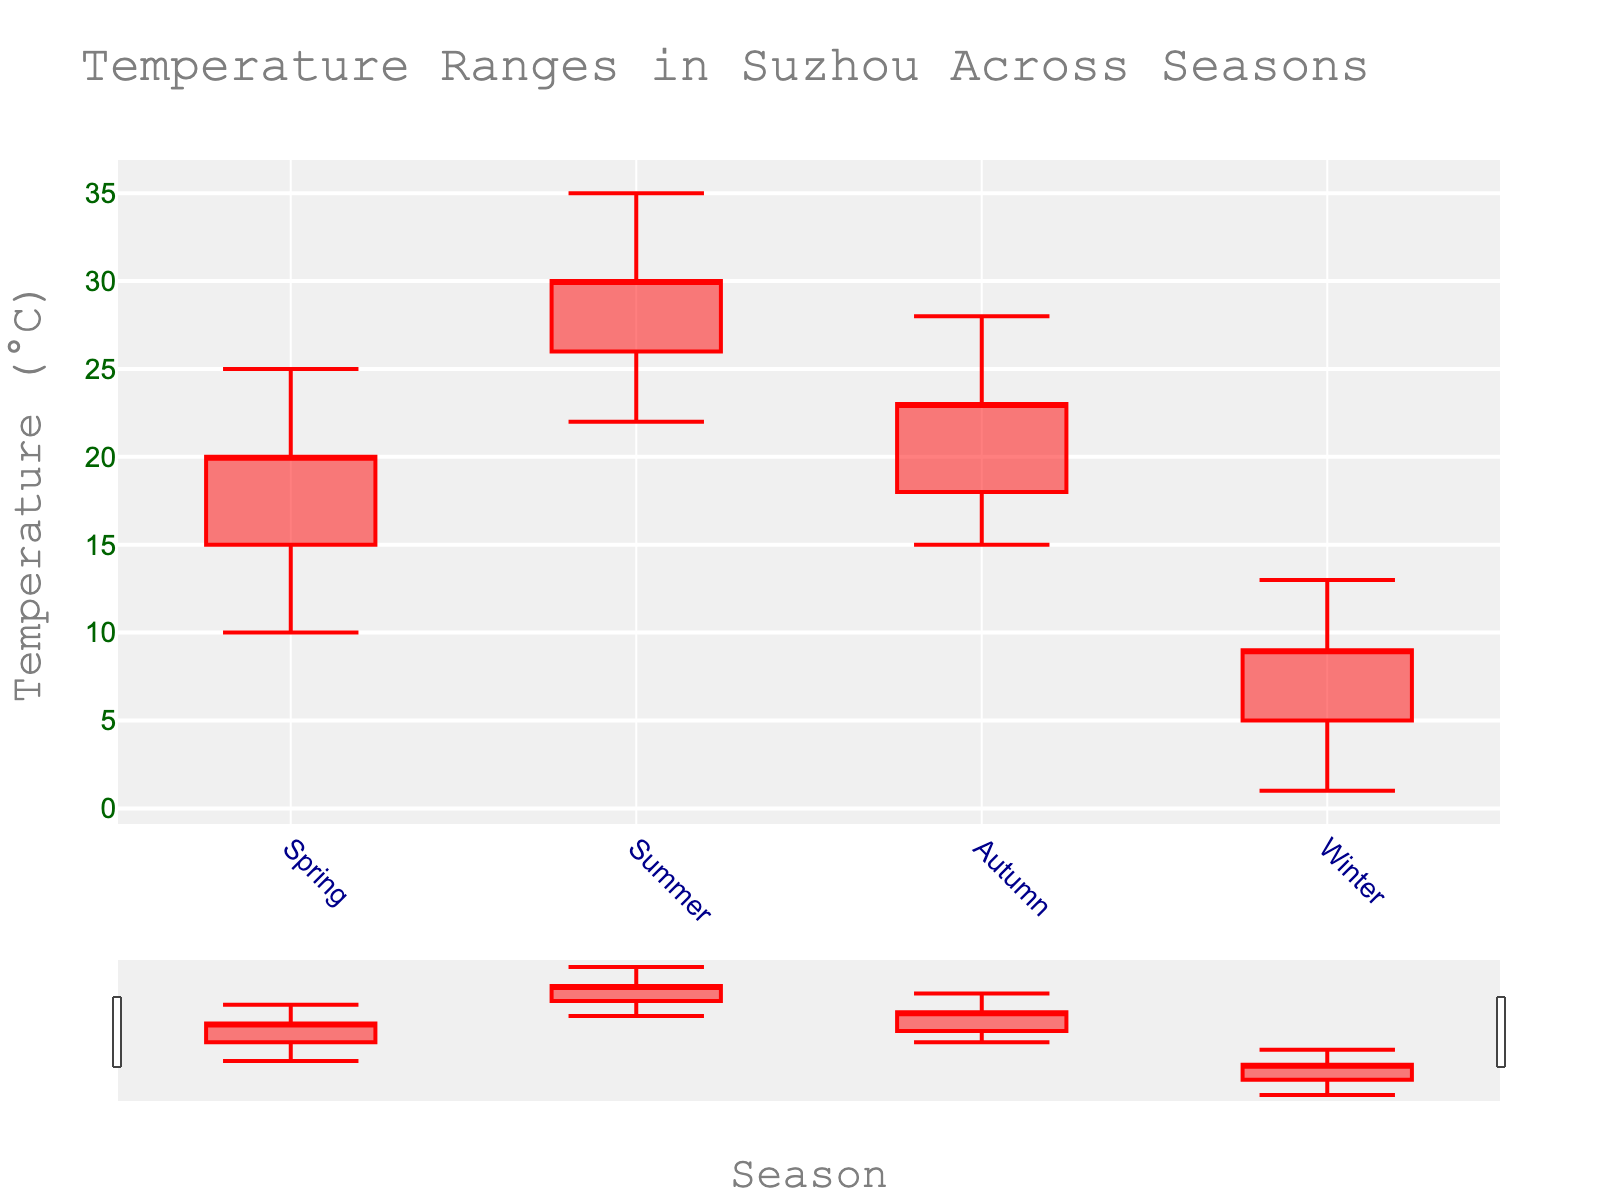What's the title of the figure? The title is usually placed at the top of the figure and summarizes the content. Here, it reads "Temperature Ranges in Suzhou Across Seasons".
Answer: Temperature Ranges in Suzhou Across Seasons What are the temperature ranges in Winter? The candlestick has four key values: Low, Open, Close, and High. For Winter, these are 1°C, 5°C, 9°C, and 13°C respectively.
Answer: 1°C, 5°C, 9°C, and 13°C Which season has the highest recorded temperature? The candlestick plot clearly shows the highest lines. Here, the highest line is in Summer at 35°C.
Answer: Summer How many seasons are depicted in the figure? The figure's x-axis labels indicate the names of the seasons, which are Spring, Summer, Autumn, and Winter. Counting these labels gives four seasons.
Answer: Four What's the difference between the highest temperature in Spring and Summer? The high for Spring is 25°C and for Summer is 35°C. Subtracting Spring's high from Summer's high gives 35°C - 25°C.
Answer: 10°C What's the range of daily temperatures in Autumn? The range can be found by subtracting the low value from the high value for Autumn. For Autumn, this is 28°C - 15°C.
Answer: 13°C In which season is the difference between Low and Open temperatures the smallest? Looking at the differences for each season: Spring (15°C - 10°C = 5°C), Summer (26°C - 22°C = 4°C), Autumn (18°C - 15°C = 3°C), Winter (5°C - 1°C = 4°C), Autumn has the smallest difference of 3°C.
Answer: Autumn What's the mean value of the high temperatures across all seasons? Sum the high temperatures for all seasons (25°C + 35°C + 28°C + 13°C) and divide by the number of seasons (4). This gives (25 + 35 + 28 + 13) / 4.
Answer: 25.25°C Which season witnesses the largest difference between its Open and Close temperatures? Calculate the differences for each season: Spring (20°C - 15°C = 5°C), Summer (30°C - 26°C = 4°C), Autumn (23°C - 18°C = 5°C), Winter (9°C - 5°C = 4°C). Spring and Autumn both have the largest difference of 5°C.
Answer: Spring and Autumn 